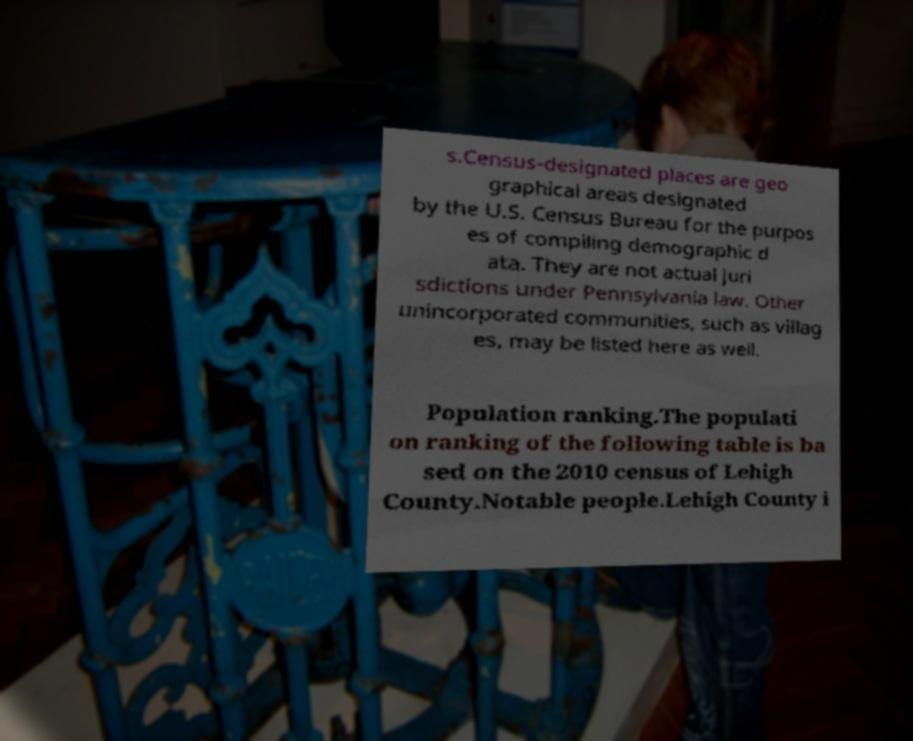Can you read and provide the text displayed in the image?This photo seems to have some interesting text. Can you extract and type it out for me? s.Census-designated places are geo graphical areas designated by the U.S. Census Bureau for the purpos es of compiling demographic d ata. They are not actual juri sdictions under Pennsylvania law. Other unincorporated communities, such as villag es, may be listed here as well. Population ranking.The populati on ranking of the following table is ba sed on the 2010 census of Lehigh County.Notable people.Lehigh County i 